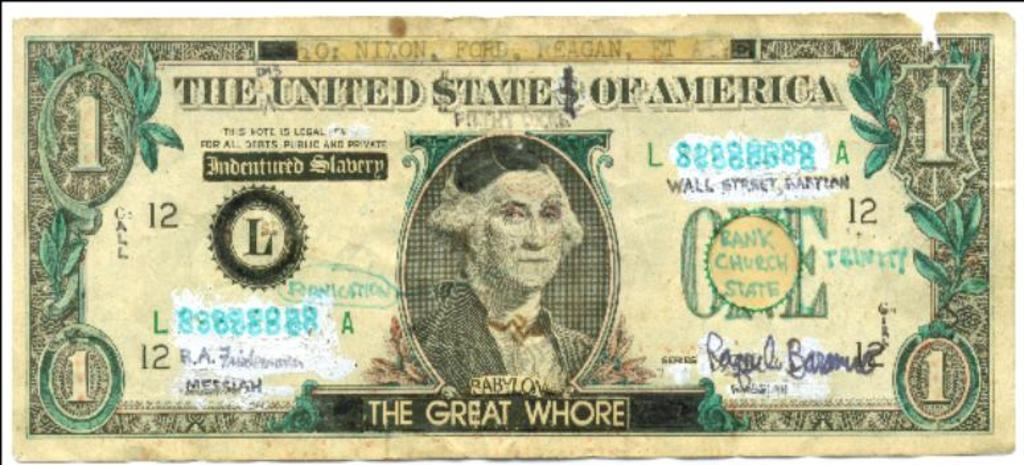<image>
Give a short and clear explanation of the subsequent image. The Great Whore is written on a dollar bill 